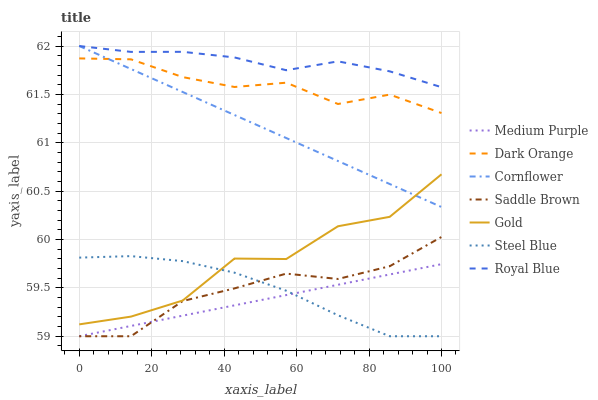Does Gold have the minimum area under the curve?
Answer yes or no. No. Does Gold have the maximum area under the curve?
Answer yes or no. No. Is Cornflower the smoothest?
Answer yes or no. No. Is Cornflower the roughest?
Answer yes or no. No. Does Gold have the lowest value?
Answer yes or no. No. Does Gold have the highest value?
Answer yes or no. No. Is Gold less than Royal Blue?
Answer yes or no. Yes. Is Royal Blue greater than Medium Purple?
Answer yes or no. Yes. Does Gold intersect Royal Blue?
Answer yes or no. No. 